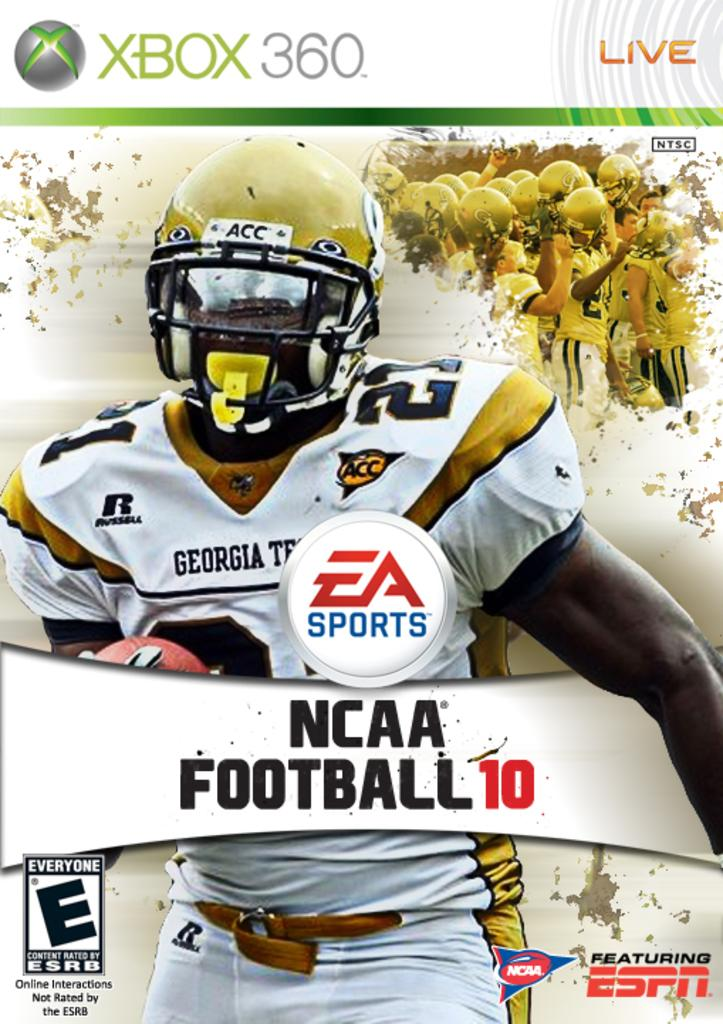What is present in the picture that contains information or visuals? There is a poster in the picture. What types of elements can be found on the poster? The poster contains logos, words, numbers, and images. Can you describe the cave that is present in the image? There is no cave present in the image; the image only contains a poster with various elements. What type of paint is used to create the images on the poster? The image does not provide information about the type of paint used, as it only shows the poster and its contents. 